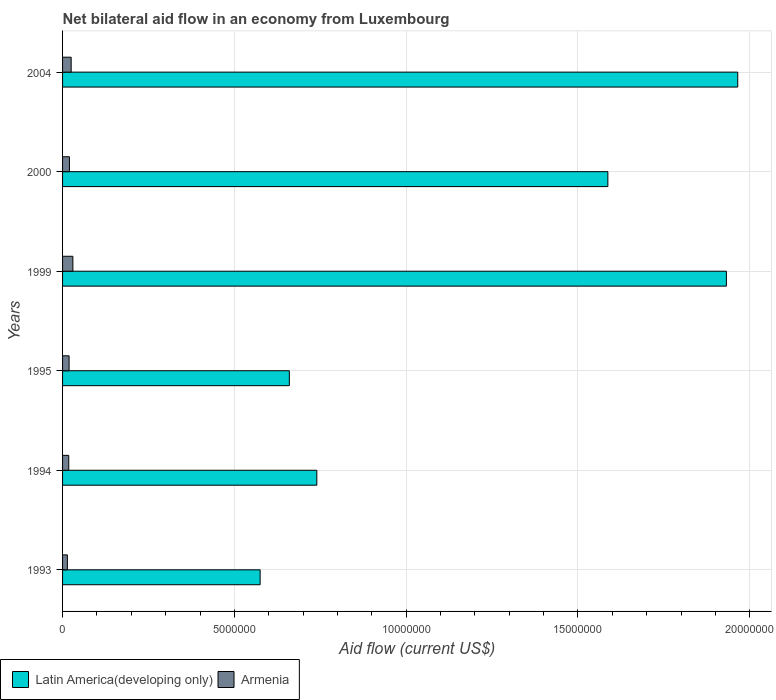How many different coloured bars are there?
Make the answer very short. 2. How many groups of bars are there?
Ensure brevity in your answer.  6. Are the number of bars on each tick of the Y-axis equal?
Your response must be concise. Yes. How many bars are there on the 3rd tick from the bottom?
Keep it short and to the point. 2. What is the label of the 2nd group of bars from the top?
Provide a succinct answer. 2000. Across all years, what is the minimum net bilateral aid flow in Latin America(developing only)?
Make the answer very short. 5.75e+06. In which year was the net bilateral aid flow in Armenia maximum?
Offer a very short reply. 1999. What is the total net bilateral aid flow in Latin America(developing only) in the graph?
Give a very brief answer. 7.46e+07. What is the difference between the net bilateral aid flow in Armenia in 1999 and that in 2000?
Ensure brevity in your answer.  1.00e+05. What is the difference between the net bilateral aid flow in Latin America(developing only) in 1993 and the net bilateral aid flow in Armenia in 1995?
Offer a very short reply. 5.56e+06. What is the average net bilateral aid flow in Latin America(developing only) per year?
Provide a succinct answer. 1.24e+07. In the year 2000, what is the difference between the net bilateral aid flow in Armenia and net bilateral aid flow in Latin America(developing only)?
Provide a short and direct response. -1.57e+07. What is the ratio of the net bilateral aid flow in Armenia in 1993 to that in 1994?
Offer a terse response. 0.78. Is the difference between the net bilateral aid flow in Armenia in 1994 and 2004 greater than the difference between the net bilateral aid flow in Latin America(developing only) in 1994 and 2004?
Keep it short and to the point. Yes. What is the difference between the highest and the second highest net bilateral aid flow in Latin America(developing only)?
Offer a terse response. 3.30e+05. What is the difference between the highest and the lowest net bilateral aid flow in Armenia?
Offer a very short reply. 1.60e+05. In how many years, is the net bilateral aid flow in Armenia greater than the average net bilateral aid flow in Armenia taken over all years?
Give a very brief answer. 2. What does the 2nd bar from the top in 1994 represents?
Provide a succinct answer. Latin America(developing only). What does the 2nd bar from the bottom in 1999 represents?
Provide a succinct answer. Armenia. How many years are there in the graph?
Provide a short and direct response. 6. Does the graph contain any zero values?
Provide a succinct answer. No. Does the graph contain grids?
Offer a terse response. Yes. Where does the legend appear in the graph?
Provide a short and direct response. Bottom left. How many legend labels are there?
Make the answer very short. 2. How are the legend labels stacked?
Offer a very short reply. Horizontal. What is the title of the graph?
Keep it short and to the point. Net bilateral aid flow in an economy from Luxembourg. What is the Aid flow (current US$) in Latin America(developing only) in 1993?
Make the answer very short. 5.75e+06. What is the Aid flow (current US$) in Latin America(developing only) in 1994?
Offer a terse response. 7.40e+06. What is the Aid flow (current US$) of Armenia in 1994?
Your answer should be compact. 1.80e+05. What is the Aid flow (current US$) in Latin America(developing only) in 1995?
Make the answer very short. 6.60e+06. What is the Aid flow (current US$) in Armenia in 1995?
Provide a succinct answer. 1.90e+05. What is the Aid flow (current US$) of Latin America(developing only) in 1999?
Provide a succinct answer. 1.93e+07. What is the Aid flow (current US$) of Latin America(developing only) in 2000?
Your response must be concise. 1.59e+07. What is the Aid flow (current US$) in Latin America(developing only) in 2004?
Give a very brief answer. 1.96e+07. Across all years, what is the maximum Aid flow (current US$) of Latin America(developing only)?
Offer a terse response. 1.96e+07. Across all years, what is the maximum Aid flow (current US$) in Armenia?
Offer a terse response. 3.00e+05. Across all years, what is the minimum Aid flow (current US$) of Latin America(developing only)?
Offer a terse response. 5.75e+06. What is the total Aid flow (current US$) of Latin America(developing only) in the graph?
Keep it short and to the point. 7.46e+07. What is the total Aid flow (current US$) of Armenia in the graph?
Provide a succinct answer. 1.26e+06. What is the difference between the Aid flow (current US$) in Latin America(developing only) in 1993 and that in 1994?
Make the answer very short. -1.65e+06. What is the difference between the Aid flow (current US$) of Armenia in 1993 and that in 1994?
Your response must be concise. -4.00e+04. What is the difference between the Aid flow (current US$) in Latin America(developing only) in 1993 and that in 1995?
Ensure brevity in your answer.  -8.50e+05. What is the difference between the Aid flow (current US$) of Armenia in 1993 and that in 1995?
Your response must be concise. -5.00e+04. What is the difference between the Aid flow (current US$) in Latin America(developing only) in 1993 and that in 1999?
Ensure brevity in your answer.  -1.36e+07. What is the difference between the Aid flow (current US$) in Armenia in 1993 and that in 1999?
Give a very brief answer. -1.60e+05. What is the difference between the Aid flow (current US$) in Latin America(developing only) in 1993 and that in 2000?
Keep it short and to the point. -1.01e+07. What is the difference between the Aid flow (current US$) of Latin America(developing only) in 1993 and that in 2004?
Make the answer very short. -1.39e+07. What is the difference between the Aid flow (current US$) in Armenia in 1993 and that in 2004?
Your answer should be compact. -1.10e+05. What is the difference between the Aid flow (current US$) in Latin America(developing only) in 1994 and that in 1999?
Make the answer very short. -1.19e+07. What is the difference between the Aid flow (current US$) of Armenia in 1994 and that in 1999?
Offer a very short reply. -1.20e+05. What is the difference between the Aid flow (current US$) in Latin America(developing only) in 1994 and that in 2000?
Ensure brevity in your answer.  -8.47e+06. What is the difference between the Aid flow (current US$) in Armenia in 1994 and that in 2000?
Offer a very short reply. -2.00e+04. What is the difference between the Aid flow (current US$) of Latin America(developing only) in 1994 and that in 2004?
Make the answer very short. -1.22e+07. What is the difference between the Aid flow (current US$) of Armenia in 1994 and that in 2004?
Provide a short and direct response. -7.00e+04. What is the difference between the Aid flow (current US$) of Latin America(developing only) in 1995 and that in 1999?
Provide a short and direct response. -1.27e+07. What is the difference between the Aid flow (current US$) of Armenia in 1995 and that in 1999?
Make the answer very short. -1.10e+05. What is the difference between the Aid flow (current US$) in Latin America(developing only) in 1995 and that in 2000?
Provide a short and direct response. -9.27e+06. What is the difference between the Aid flow (current US$) in Armenia in 1995 and that in 2000?
Your answer should be very brief. -10000. What is the difference between the Aid flow (current US$) of Latin America(developing only) in 1995 and that in 2004?
Make the answer very short. -1.30e+07. What is the difference between the Aid flow (current US$) in Armenia in 1995 and that in 2004?
Your answer should be very brief. -6.00e+04. What is the difference between the Aid flow (current US$) of Latin America(developing only) in 1999 and that in 2000?
Provide a succinct answer. 3.45e+06. What is the difference between the Aid flow (current US$) in Armenia in 1999 and that in 2000?
Make the answer very short. 1.00e+05. What is the difference between the Aid flow (current US$) in Latin America(developing only) in 1999 and that in 2004?
Provide a short and direct response. -3.30e+05. What is the difference between the Aid flow (current US$) in Latin America(developing only) in 2000 and that in 2004?
Offer a terse response. -3.78e+06. What is the difference between the Aid flow (current US$) of Armenia in 2000 and that in 2004?
Your answer should be compact. -5.00e+04. What is the difference between the Aid flow (current US$) of Latin America(developing only) in 1993 and the Aid flow (current US$) of Armenia in 1994?
Ensure brevity in your answer.  5.57e+06. What is the difference between the Aid flow (current US$) in Latin America(developing only) in 1993 and the Aid flow (current US$) in Armenia in 1995?
Your response must be concise. 5.56e+06. What is the difference between the Aid flow (current US$) in Latin America(developing only) in 1993 and the Aid flow (current US$) in Armenia in 1999?
Your response must be concise. 5.45e+06. What is the difference between the Aid flow (current US$) of Latin America(developing only) in 1993 and the Aid flow (current US$) of Armenia in 2000?
Make the answer very short. 5.55e+06. What is the difference between the Aid flow (current US$) in Latin America(developing only) in 1993 and the Aid flow (current US$) in Armenia in 2004?
Keep it short and to the point. 5.50e+06. What is the difference between the Aid flow (current US$) of Latin America(developing only) in 1994 and the Aid flow (current US$) of Armenia in 1995?
Ensure brevity in your answer.  7.21e+06. What is the difference between the Aid flow (current US$) of Latin America(developing only) in 1994 and the Aid flow (current US$) of Armenia in 1999?
Offer a terse response. 7.10e+06. What is the difference between the Aid flow (current US$) of Latin America(developing only) in 1994 and the Aid flow (current US$) of Armenia in 2000?
Provide a succinct answer. 7.20e+06. What is the difference between the Aid flow (current US$) in Latin America(developing only) in 1994 and the Aid flow (current US$) in Armenia in 2004?
Provide a succinct answer. 7.15e+06. What is the difference between the Aid flow (current US$) in Latin America(developing only) in 1995 and the Aid flow (current US$) in Armenia in 1999?
Offer a terse response. 6.30e+06. What is the difference between the Aid flow (current US$) of Latin America(developing only) in 1995 and the Aid flow (current US$) of Armenia in 2000?
Make the answer very short. 6.40e+06. What is the difference between the Aid flow (current US$) of Latin America(developing only) in 1995 and the Aid flow (current US$) of Armenia in 2004?
Give a very brief answer. 6.35e+06. What is the difference between the Aid flow (current US$) in Latin America(developing only) in 1999 and the Aid flow (current US$) in Armenia in 2000?
Your answer should be compact. 1.91e+07. What is the difference between the Aid flow (current US$) in Latin America(developing only) in 1999 and the Aid flow (current US$) in Armenia in 2004?
Make the answer very short. 1.91e+07. What is the difference between the Aid flow (current US$) in Latin America(developing only) in 2000 and the Aid flow (current US$) in Armenia in 2004?
Ensure brevity in your answer.  1.56e+07. What is the average Aid flow (current US$) of Latin America(developing only) per year?
Your answer should be compact. 1.24e+07. What is the average Aid flow (current US$) of Armenia per year?
Ensure brevity in your answer.  2.10e+05. In the year 1993, what is the difference between the Aid flow (current US$) of Latin America(developing only) and Aid flow (current US$) of Armenia?
Provide a succinct answer. 5.61e+06. In the year 1994, what is the difference between the Aid flow (current US$) in Latin America(developing only) and Aid flow (current US$) in Armenia?
Your response must be concise. 7.22e+06. In the year 1995, what is the difference between the Aid flow (current US$) in Latin America(developing only) and Aid flow (current US$) in Armenia?
Make the answer very short. 6.41e+06. In the year 1999, what is the difference between the Aid flow (current US$) of Latin America(developing only) and Aid flow (current US$) of Armenia?
Ensure brevity in your answer.  1.90e+07. In the year 2000, what is the difference between the Aid flow (current US$) of Latin America(developing only) and Aid flow (current US$) of Armenia?
Your answer should be compact. 1.57e+07. In the year 2004, what is the difference between the Aid flow (current US$) in Latin America(developing only) and Aid flow (current US$) in Armenia?
Ensure brevity in your answer.  1.94e+07. What is the ratio of the Aid flow (current US$) in Latin America(developing only) in 1993 to that in 1994?
Provide a short and direct response. 0.78. What is the ratio of the Aid flow (current US$) of Latin America(developing only) in 1993 to that in 1995?
Provide a short and direct response. 0.87. What is the ratio of the Aid flow (current US$) in Armenia in 1993 to that in 1995?
Offer a terse response. 0.74. What is the ratio of the Aid flow (current US$) in Latin America(developing only) in 1993 to that in 1999?
Your answer should be very brief. 0.3. What is the ratio of the Aid flow (current US$) of Armenia in 1993 to that in 1999?
Ensure brevity in your answer.  0.47. What is the ratio of the Aid flow (current US$) of Latin America(developing only) in 1993 to that in 2000?
Ensure brevity in your answer.  0.36. What is the ratio of the Aid flow (current US$) in Latin America(developing only) in 1993 to that in 2004?
Keep it short and to the point. 0.29. What is the ratio of the Aid flow (current US$) of Armenia in 1993 to that in 2004?
Offer a terse response. 0.56. What is the ratio of the Aid flow (current US$) of Latin America(developing only) in 1994 to that in 1995?
Your answer should be compact. 1.12. What is the ratio of the Aid flow (current US$) of Armenia in 1994 to that in 1995?
Ensure brevity in your answer.  0.95. What is the ratio of the Aid flow (current US$) in Latin America(developing only) in 1994 to that in 1999?
Offer a terse response. 0.38. What is the ratio of the Aid flow (current US$) of Latin America(developing only) in 1994 to that in 2000?
Your answer should be compact. 0.47. What is the ratio of the Aid flow (current US$) in Armenia in 1994 to that in 2000?
Provide a short and direct response. 0.9. What is the ratio of the Aid flow (current US$) of Latin America(developing only) in 1994 to that in 2004?
Give a very brief answer. 0.38. What is the ratio of the Aid flow (current US$) in Armenia in 1994 to that in 2004?
Keep it short and to the point. 0.72. What is the ratio of the Aid flow (current US$) in Latin America(developing only) in 1995 to that in 1999?
Your answer should be very brief. 0.34. What is the ratio of the Aid flow (current US$) of Armenia in 1995 to that in 1999?
Make the answer very short. 0.63. What is the ratio of the Aid flow (current US$) of Latin America(developing only) in 1995 to that in 2000?
Offer a very short reply. 0.42. What is the ratio of the Aid flow (current US$) in Armenia in 1995 to that in 2000?
Offer a very short reply. 0.95. What is the ratio of the Aid flow (current US$) in Latin America(developing only) in 1995 to that in 2004?
Give a very brief answer. 0.34. What is the ratio of the Aid flow (current US$) in Armenia in 1995 to that in 2004?
Provide a succinct answer. 0.76. What is the ratio of the Aid flow (current US$) of Latin America(developing only) in 1999 to that in 2000?
Give a very brief answer. 1.22. What is the ratio of the Aid flow (current US$) in Armenia in 1999 to that in 2000?
Ensure brevity in your answer.  1.5. What is the ratio of the Aid flow (current US$) in Latin America(developing only) in 1999 to that in 2004?
Provide a succinct answer. 0.98. What is the ratio of the Aid flow (current US$) of Latin America(developing only) in 2000 to that in 2004?
Provide a short and direct response. 0.81. What is the difference between the highest and the second highest Aid flow (current US$) in Latin America(developing only)?
Make the answer very short. 3.30e+05. What is the difference between the highest and the second highest Aid flow (current US$) in Armenia?
Provide a short and direct response. 5.00e+04. What is the difference between the highest and the lowest Aid flow (current US$) of Latin America(developing only)?
Provide a succinct answer. 1.39e+07. What is the difference between the highest and the lowest Aid flow (current US$) in Armenia?
Your response must be concise. 1.60e+05. 